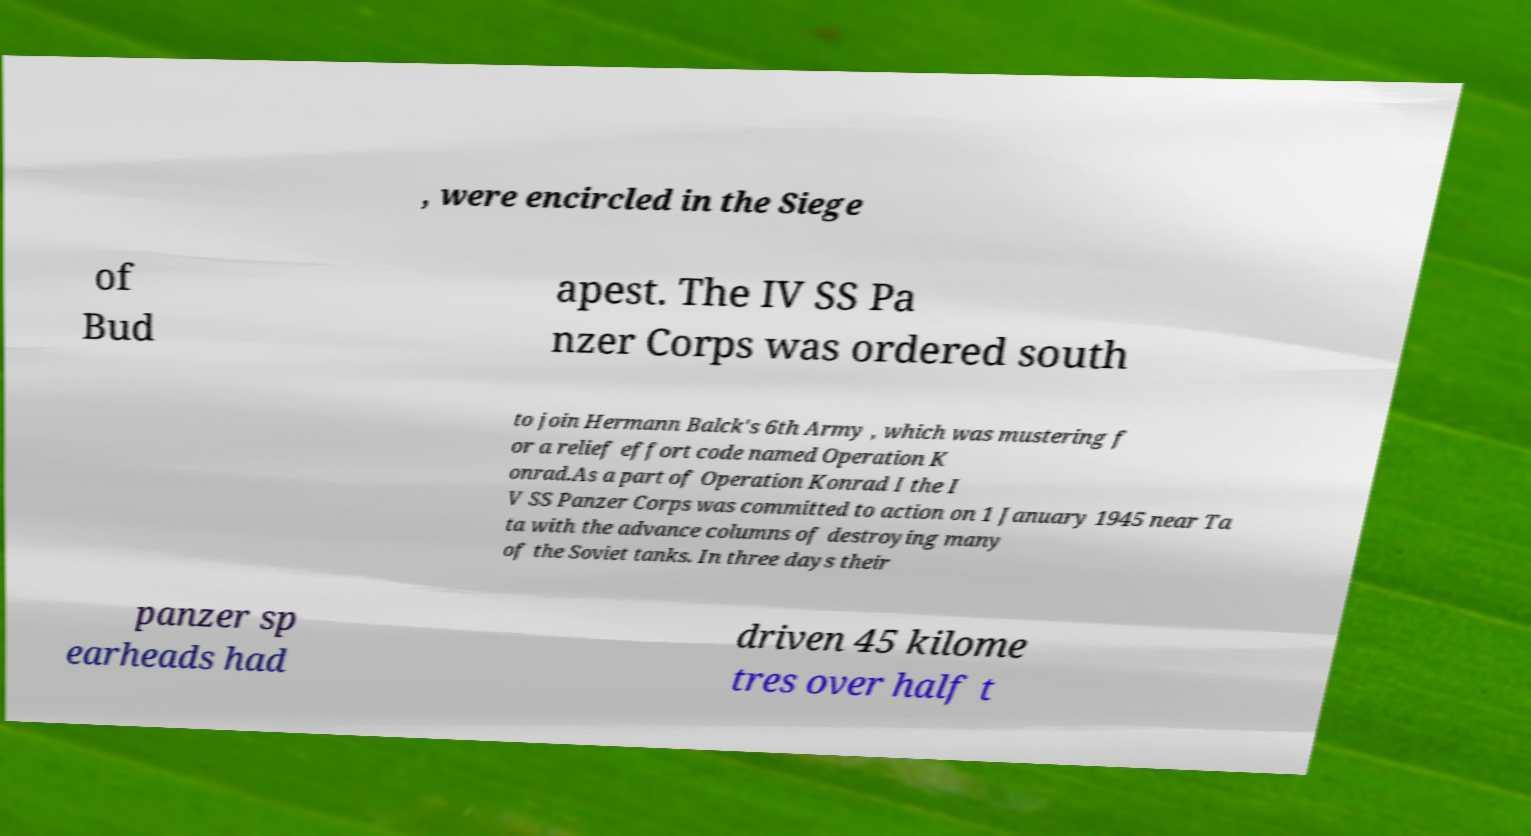For documentation purposes, I need the text within this image transcribed. Could you provide that? , were encircled in the Siege of Bud apest. The IV SS Pa nzer Corps was ordered south to join Hermann Balck's 6th Army , which was mustering f or a relief effort code named Operation K onrad.As a part of Operation Konrad I the I V SS Panzer Corps was committed to action on 1 January 1945 near Ta ta with the advance columns of destroying many of the Soviet tanks. In three days their panzer sp earheads had driven 45 kilome tres over half t 